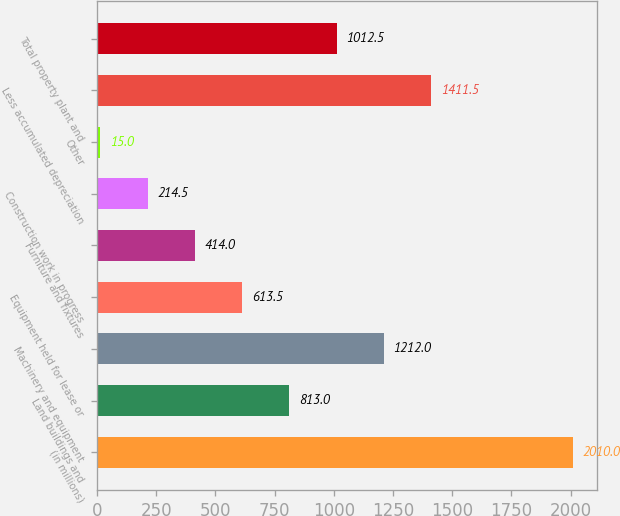<chart> <loc_0><loc_0><loc_500><loc_500><bar_chart><fcel>(in millions)<fcel>Land buildings and<fcel>Machinery and equipment<fcel>Equipment held for lease or<fcel>Furniture and fixtures<fcel>Construction work in progress<fcel>Other<fcel>Less accumulated depreciation<fcel>Total property plant and<nl><fcel>2010<fcel>813<fcel>1212<fcel>613.5<fcel>414<fcel>214.5<fcel>15<fcel>1411.5<fcel>1012.5<nl></chart> 